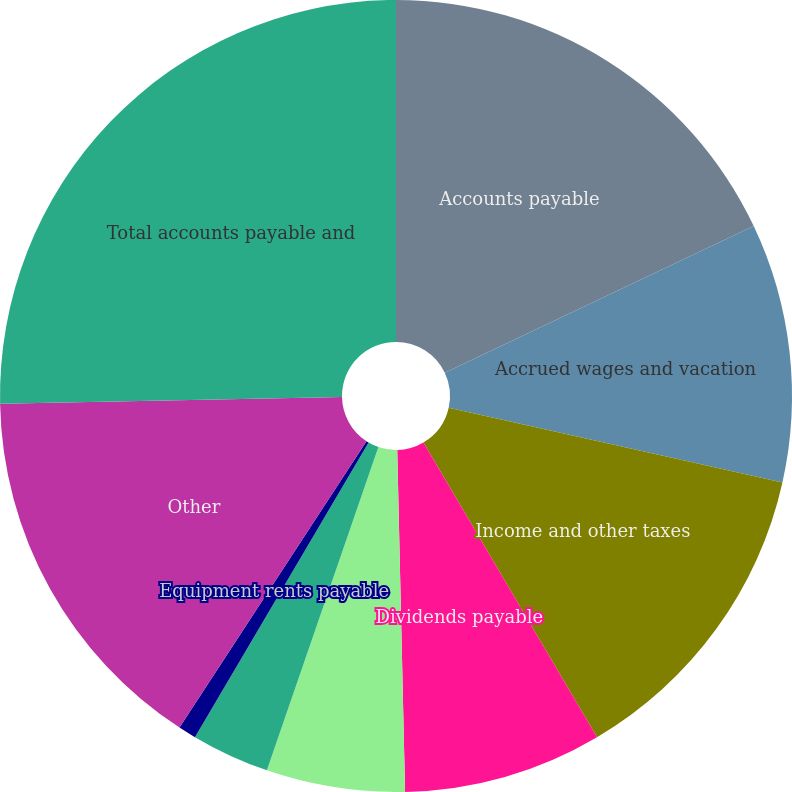Convert chart. <chart><loc_0><loc_0><loc_500><loc_500><pie_chart><fcel>Accounts payable<fcel>Accrued wages and vacation<fcel>Income and other taxes<fcel>Dividends payable<fcel>Accrued casualty costs<fcel>Interest payable<fcel>Equipment rents payable<fcel>Other<fcel>Total accounts payable and<nl><fcel>17.94%<fcel>10.56%<fcel>13.02%<fcel>8.11%<fcel>5.65%<fcel>3.19%<fcel>0.73%<fcel>15.48%<fcel>25.31%<nl></chart> 